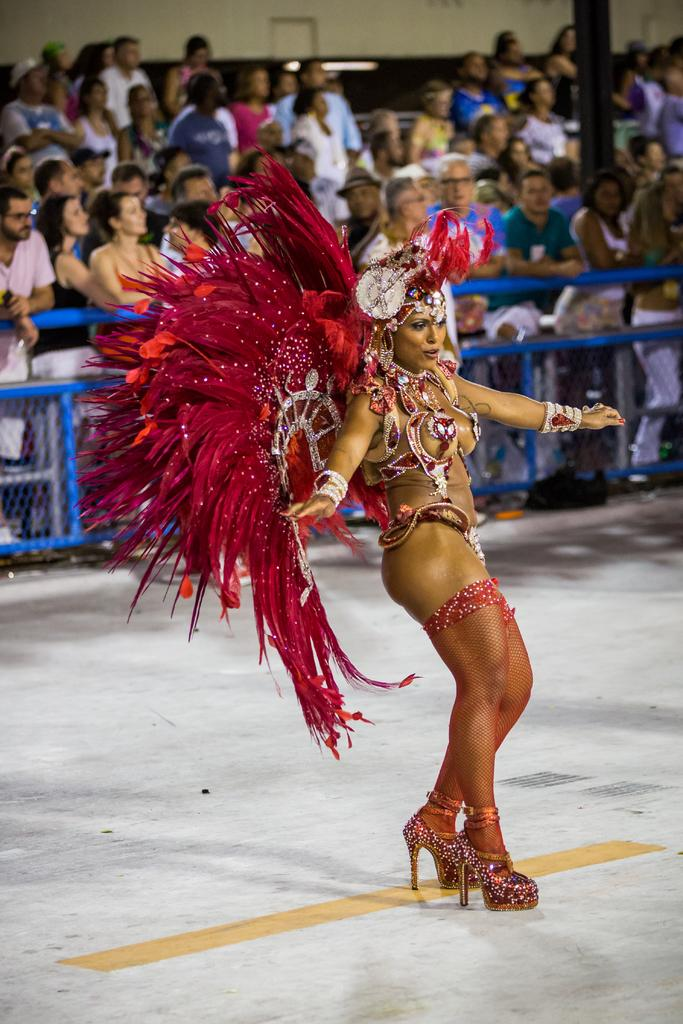What is the woman in the image doing? The woman is performing in the image. Where is the woman performing? The woman is performing on the ground. What can be seen in the background of the image? There is a fencing, a group of persons, and a wall in the background of the image. Can you see a snake slithering near the wall in the image? There is no snake present in the image. What type of fruit is being used to change the woman's costume during her performance? There is no fruit, such as quince, being used to change the woman's costume in the image. 